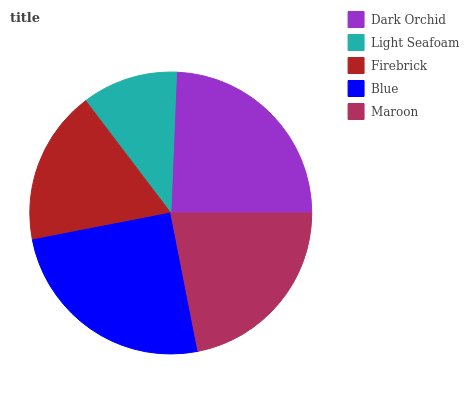Is Light Seafoam the minimum?
Answer yes or no. Yes. Is Blue the maximum?
Answer yes or no. Yes. Is Firebrick the minimum?
Answer yes or no. No. Is Firebrick the maximum?
Answer yes or no. No. Is Firebrick greater than Light Seafoam?
Answer yes or no. Yes. Is Light Seafoam less than Firebrick?
Answer yes or no. Yes. Is Light Seafoam greater than Firebrick?
Answer yes or no. No. Is Firebrick less than Light Seafoam?
Answer yes or no. No. Is Maroon the high median?
Answer yes or no. Yes. Is Maroon the low median?
Answer yes or no. Yes. Is Light Seafoam the high median?
Answer yes or no. No. Is Blue the low median?
Answer yes or no. No. 